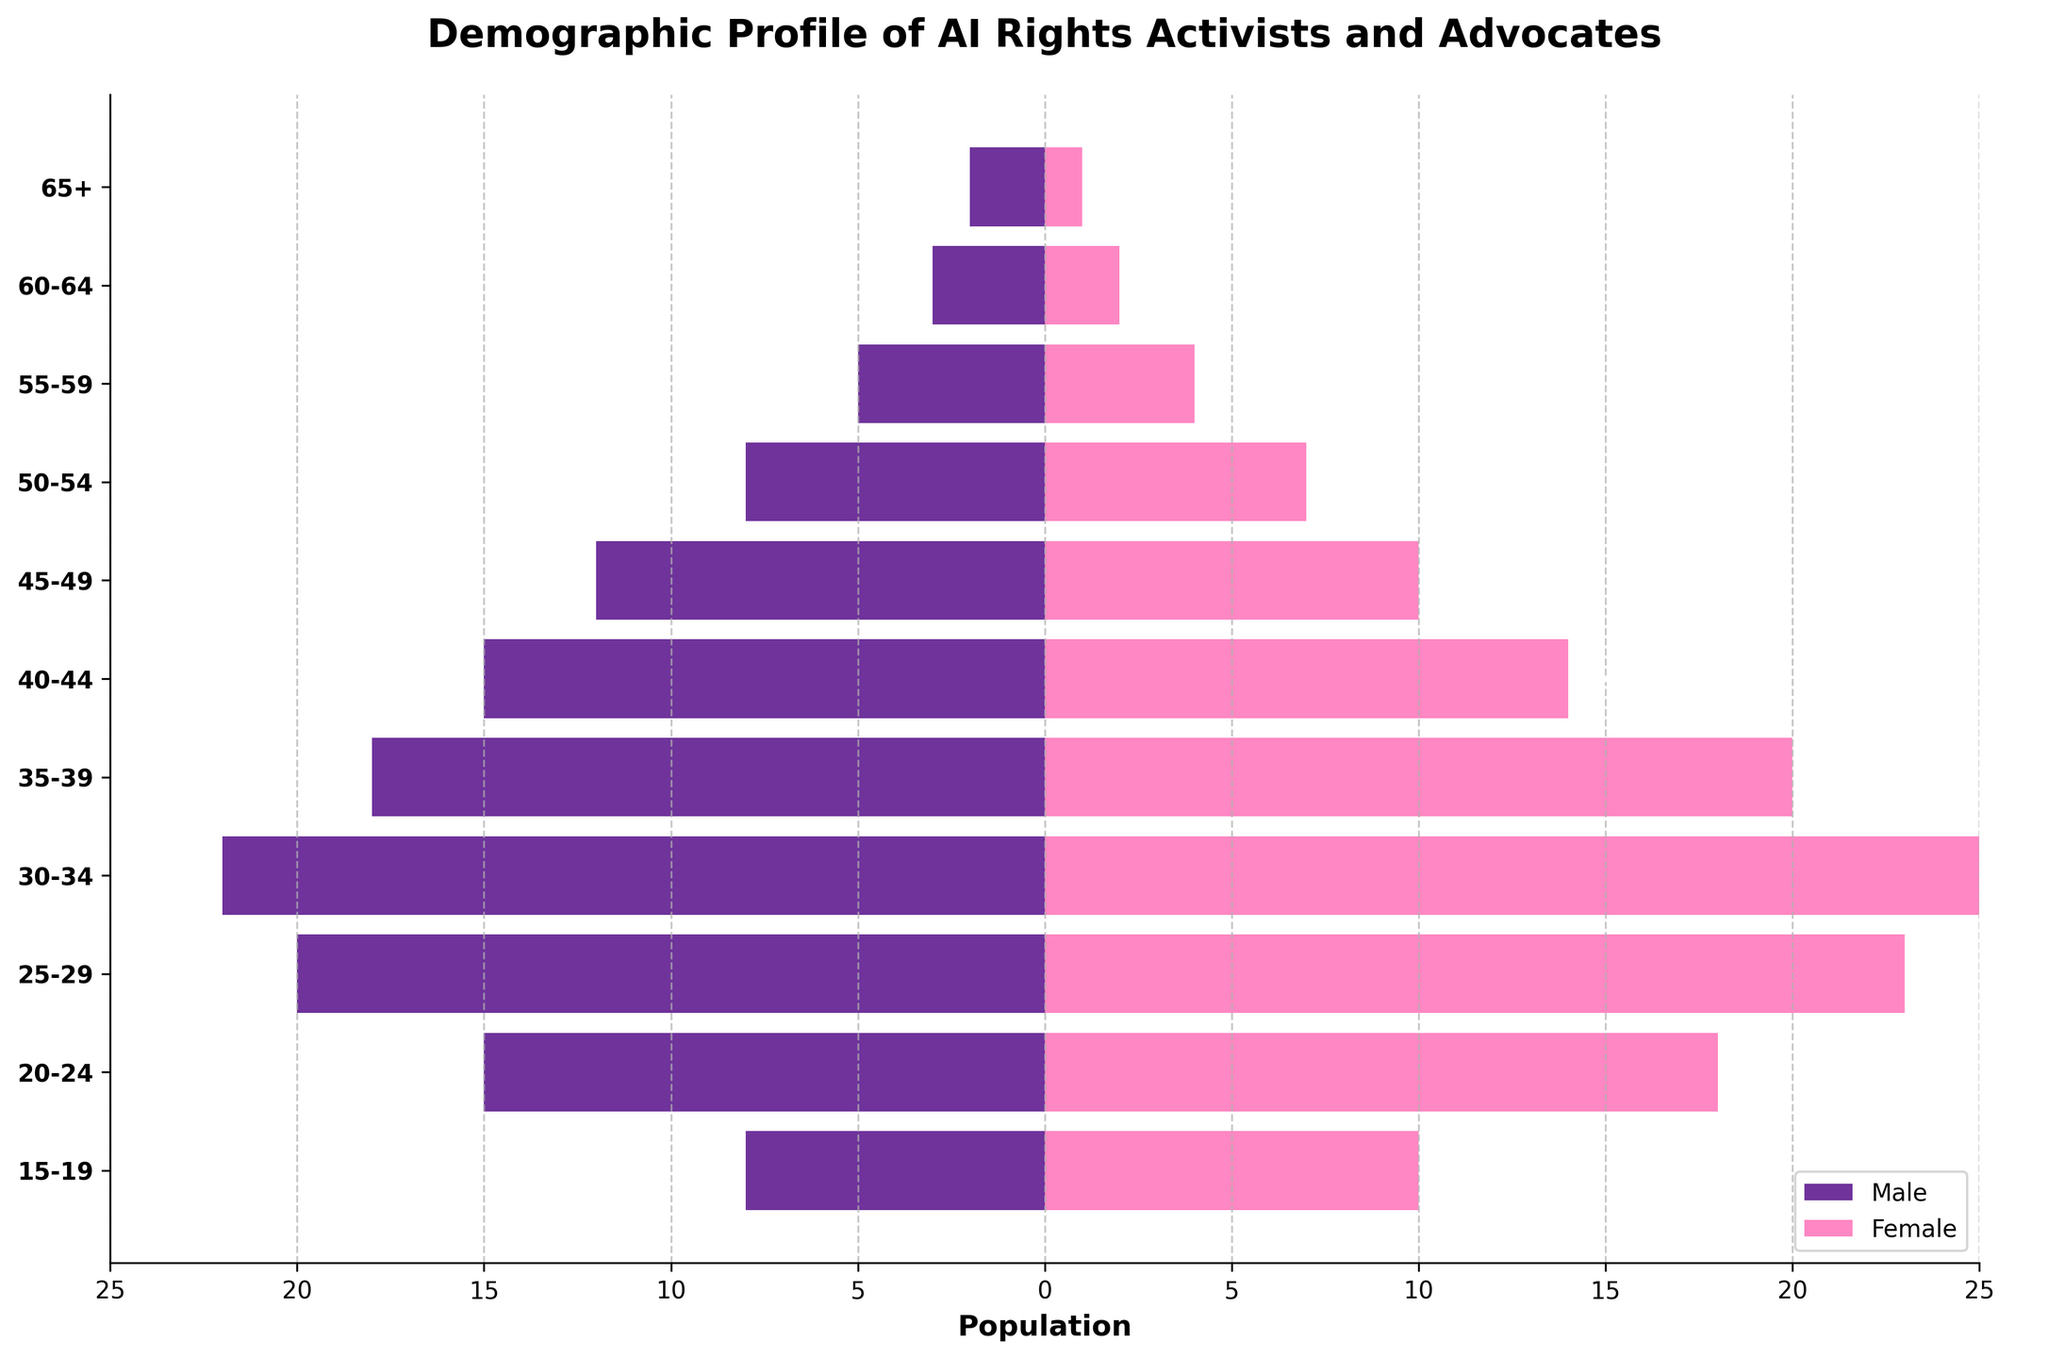Which age group has the highest number of female AI rights activists and advocates? Look at the bar representing females in each age group, and identify the one with the largest positive value. The age group "30-34" has the highest number at 25.
Answer: 30-34 What is the total population of male AI rights activists and advocates in the age groups below 40? Add the male values of all age groups below 40: 8 (15-19) + 15 (20-24) + 20 (25-29) + 22 (30-34) + 18 (35-39). The total is 83.
Answer: 83 Which two consecutive age groups show the most significant increase in the number of male activists? Measure the increase between consecutive age groups by subtracting the earlier value from the later one. The largest increase is between "15-19" (8) and "20-24" (15), which gives an increase of 7.
Answer: 15-19 to 20-24 What is the average number of female AI rights activists and advocates across all age groups shown? Sum all the female values and divide by the number of age groups: (1+2+4+7+10+14+20+25+23+18+10) / 11. The sum is 134, so the average is 134 / 11 ≈ 12.18.
Answer: 12.18 How does the pattern of male and female activists change with age? As age increases, the total number of activists generally decreases in both groups. There is a noticeable decline after the age group of "30-34" for both genders, with more males than females in older age groups.
Answer: Decreases with age Which age group has an equal number of male and female AI rights activists and advocates? Compare the male and female values for each age group. None of the age groups have equal numbers of male and female activists.
Answer: None What is the sum of the population of female activists in the "30-34" and "35-39" age groups? Add the values of females in the "30-34" and "35-39" age groups: 25 (30-34) + 20 (35-39). The sum is 45.
Answer: 45 Between the age groups "45-49" and "50-54", who has more activists, males or females? Compare the values of males and females in these age groups. For "45-49", males are 12 and females are 10. For "50-54", males are 8 and females are 7. Males have more activists.
Answer: Males 